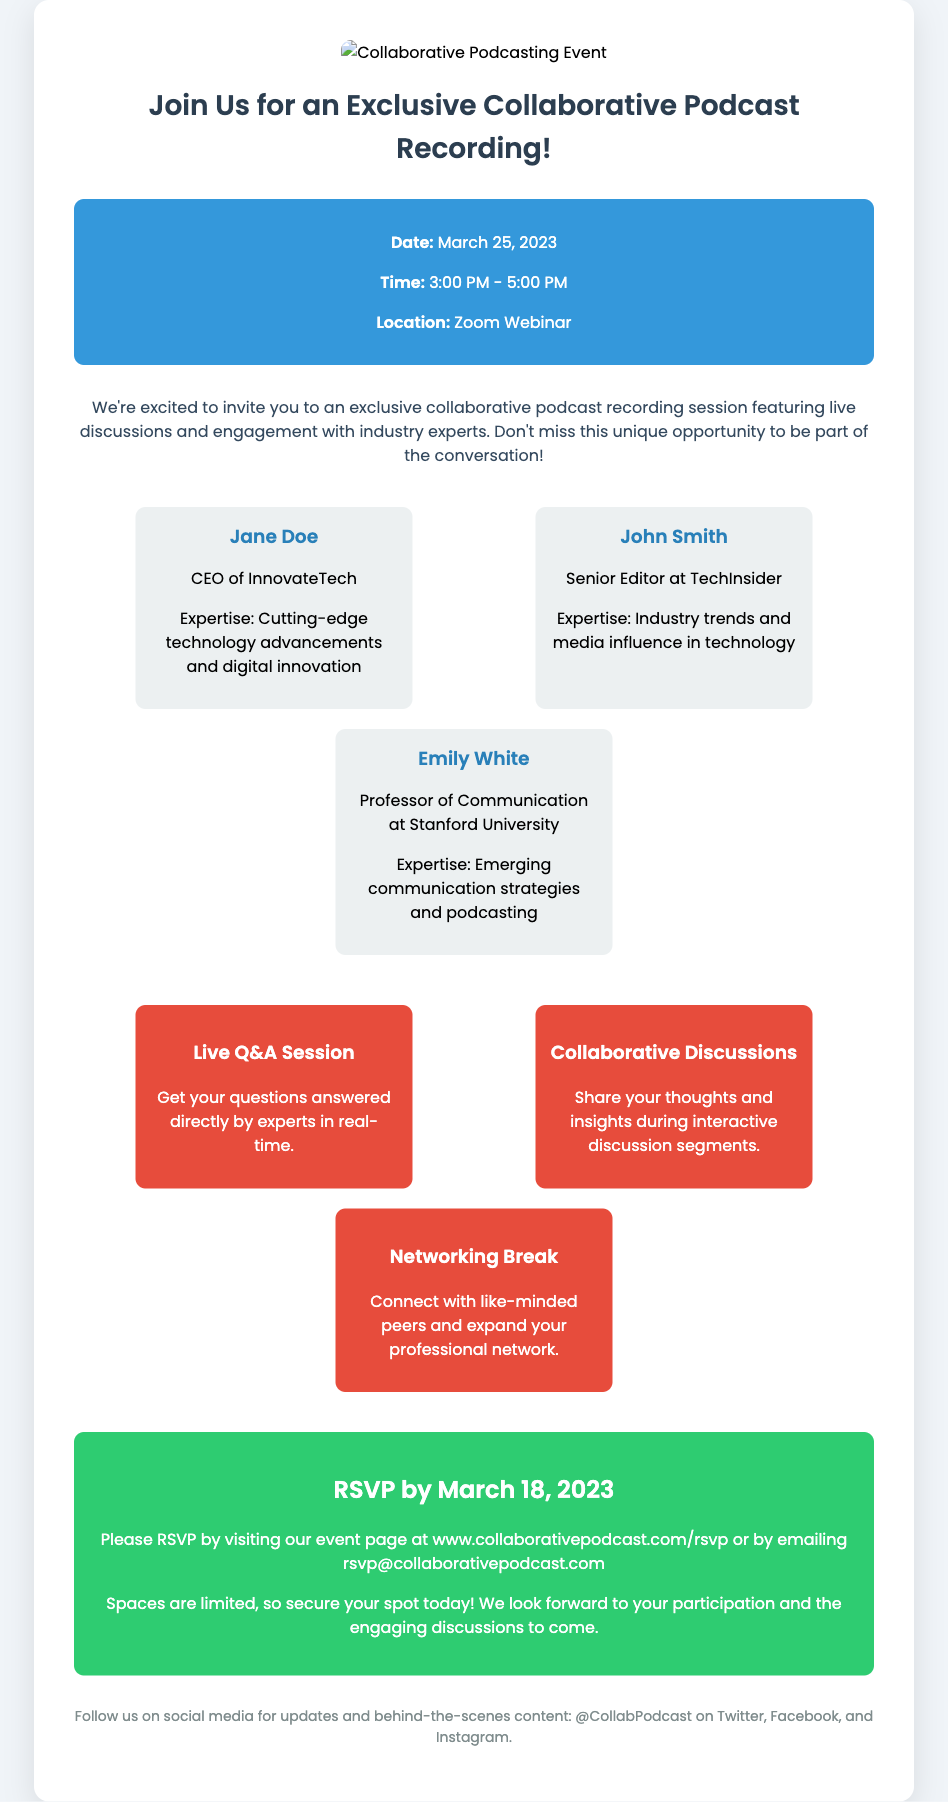What is the date of the event? The date of the event is specified in the event details section of the document.
Answer: March 25, 2023 What time does the event start? The start time of the event is provided in the event details section.
Answer: 3:00 PM Who is the CEO of InnovateTech? The name and title of the expert in the first expert section indicate this individual.
Answer: Jane Doe What opportunity involves connecting with peers? This is mentioned in the opportunities section of the document.
Answer: Networking Break What platform will the event be held on? The location of the event is mentioned in the event details.
Answer: Zoom Webinar How many experts are listed in the document? By counting the expert sections, we can determine this number.
Answer: Three What should attendees do by March 18, 2023? This action is explicitly stated in the RSVP section of the document.
Answer: RSVP What is the color of the RSVP section? The background color of the RSVP section is indicated by the style in the document.
Answer: Green What type of session allows questions to be answered directly? This opportunity is directly mentioned in the opportunities section.
Answer: Live Q&A Session 